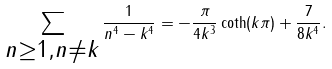<formula> <loc_0><loc_0><loc_500><loc_500>\sum _ { \substack { { n \geq 1 } , { n \neq { k } } } } \frac { 1 } { { n } ^ { 4 } - { { k } ^ { 4 } } } = - \frac { \pi } { 4 k ^ { 3 } } \coth ( k \pi ) + \frac { 7 } { 8 k ^ { 4 } } .</formula> 